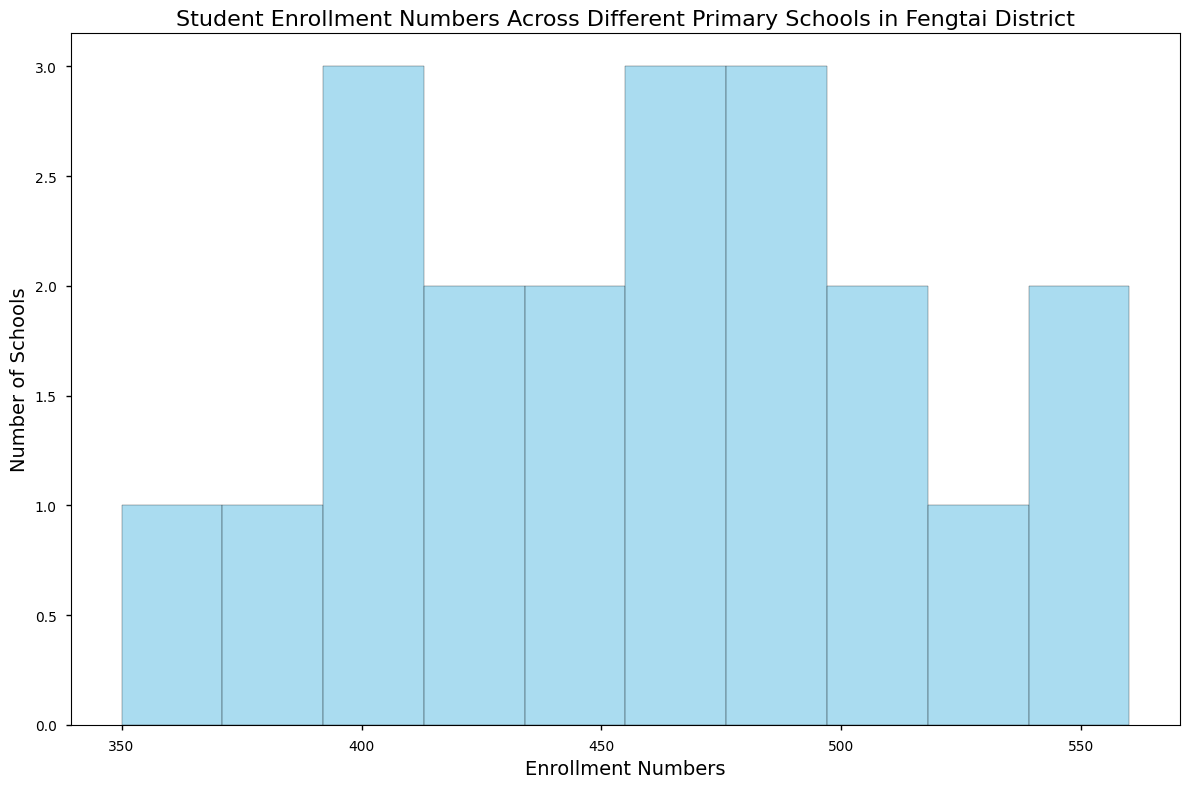What enrollment range has the highest number of schools? Simply observe the histogram to find which bin has the tallest bar, representing the range with the most schools.
Answer: 470-520 Which range of enrollment numbers contains the fewest schools? Look for the shortest bar in the histogram, which indicates the enrollment range with the fewest schools.
Answer: 350-395 How many schools have enrollment numbers between 450 and 500? Count the bars in the enrollment range of 450-500 on the histogram. The histogram shows 5 bars within this range.
Answer: 5 What is the most common enrollment numbers range? Identify the bin with the tallest bar in the histogram, as it represents the most common enrollment range.
Answer: 470-520 Which range of enrollment numbers has more schools: 400-450 or 500-550? Compare the height of the bars in the histogram for the ranges of 400-450 and 500-550. The range 400-450 has a higher bar.
Answer: 400-450 How many schools have enrollment numbers greater than 500? Add up the counts for all bins to the right of the 500 mark in the histogram. The histogram shows 3 bars for the bins (>500).
Answer: 3 Are there any schools with less than 375 students? Observe the histogram and check if there are any bars to the left of the 375 mark. The histogram shows one bar in the range of <375 (350-395).
Answer: Yes What is the mean enrollment number across all schools? Sum all enrollment numbers and divide by the total number of schools (450 + 480 + 520 + 395 + 410 + 430 + 455 + 470 + 495 + 350 + 400 + 375 + 560 + 505 + 445 + 500 + 475 + 420 + 540 + 490) / 20 = 9260 / 20. The mean is 463.
Answer: 463 